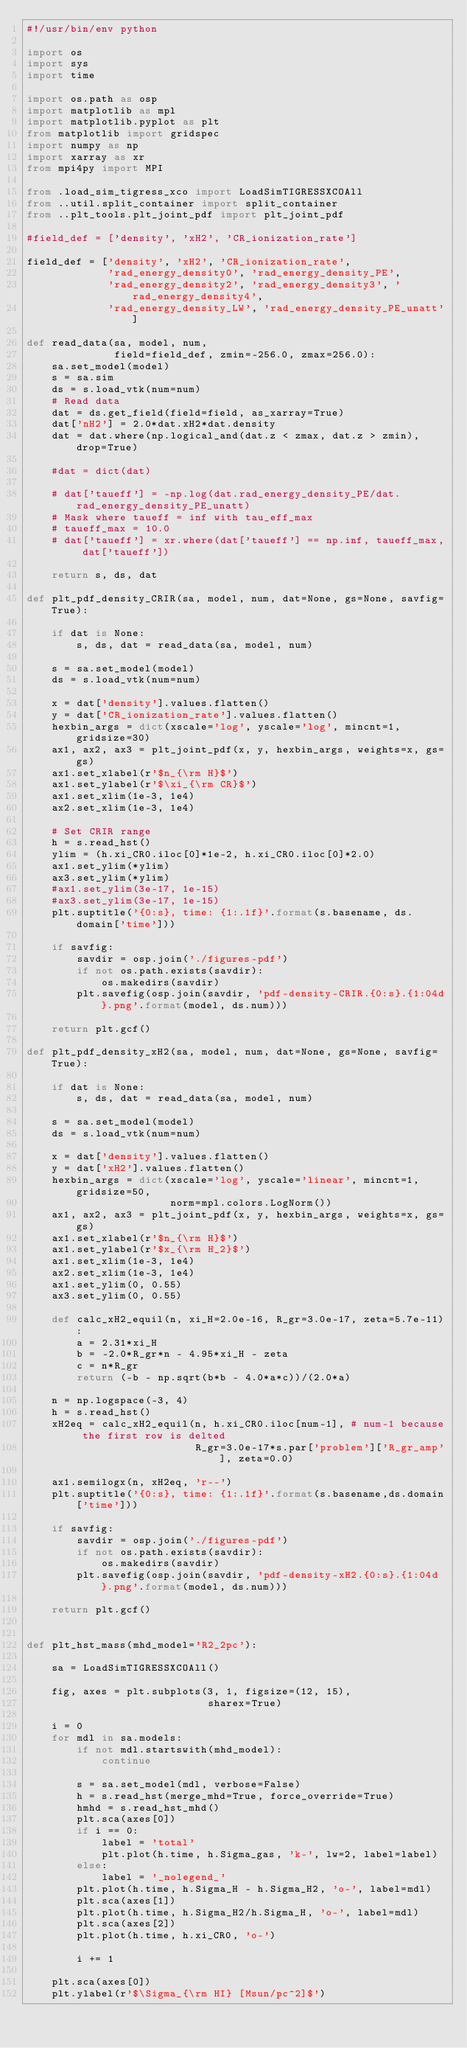<code> <loc_0><loc_0><loc_500><loc_500><_Python_>#!/usr/bin/env python

import os
import sys
import time

import os.path as osp
import matplotlib as mpl
import matplotlib.pyplot as plt
from matplotlib import gridspec
import numpy as np
import xarray as xr
from mpi4py import MPI

from .load_sim_tigress_xco import LoadSimTIGRESSXCOAll
from ..util.split_container import split_container
from ..plt_tools.plt_joint_pdf import plt_joint_pdf

#field_def = ['density', 'xH2', 'CR_ionization_rate']

field_def = ['density', 'xH2', 'CR_ionization_rate',
             'rad_energy_density0', 'rad_energy_density_PE',
             'rad_energy_density2', 'rad_energy_density3', 'rad_energy_density4',
             'rad_energy_density_LW', 'rad_energy_density_PE_unatt']

def read_data(sa, model, num,
              field=field_def, zmin=-256.0, zmax=256.0):
    sa.set_model(model)
    s = sa.sim
    ds = s.load_vtk(num=num)
    # Read data
    dat = ds.get_field(field=field, as_xarray=True)
    dat['nH2'] = 2.0*dat.xH2*dat.density
    dat = dat.where(np.logical_and(dat.z < zmax, dat.z > zmin), drop=True)

    #dat = dict(dat)

    # dat['taueff'] = -np.log(dat.rad_energy_density_PE/dat.rad_energy_density_PE_unatt)
    # Mask where taueff = inf with tau_eff_max
    # taueff_max = 10.0
    # dat['taueff'] = xr.where(dat['taueff'] == np.inf, taueff_max, dat['taueff'])
    
    return s, ds, dat

def plt_pdf_density_CRIR(sa, model, num, dat=None, gs=None, savfig=True):

    if dat is None:
        s, ds, dat = read_data(sa, model, num)

    s = sa.set_model(model)
    ds = s.load_vtk(num=num)
        
    x = dat['density'].values.flatten()
    y = dat['CR_ionization_rate'].values.flatten()
    hexbin_args = dict(xscale='log', yscale='log', mincnt=1, gridsize=30)
    ax1, ax2, ax3 = plt_joint_pdf(x, y, hexbin_args, weights=x, gs=gs)
    ax1.set_xlabel(r'$n_{\rm H}$')
    ax1.set_ylabel(r'$\xi_{\rm CR}$')
    ax1.set_xlim(1e-3, 1e4)
    ax2.set_xlim(1e-3, 1e4)

    # Set CRIR range
    h = s.read_hst()
    ylim = (h.xi_CR0.iloc[0]*1e-2, h.xi_CR0.iloc[0]*2.0)
    ax1.set_ylim(*ylim)
    ax3.set_ylim(*ylim)
    #ax1.set_ylim(3e-17, 1e-15)
    #ax3.set_ylim(3e-17, 1e-15)
    plt.suptitle('{0:s}, time: {1:.1f}'.format(s.basename, ds.domain['time']))
    
    if savfig:
        savdir = osp.join('./figures-pdf')
        if not os.path.exists(savdir):
            os.makedirs(savdir)
        plt.savefig(osp.join(savdir, 'pdf-density-CRIR.{0:s}.{1:04d}.png'.format(model, ds.num)))
    
    return plt.gcf()

def plt_pdf_density_xH2(sa, model, num, dat=None, gs=None, savfig=True):

    if dat is None:
        s, ds, dat = read_data(sa, model, num)
        
    s = sa.set_model(model)
    ds = s.load_vtk(num=num)

    x = dat['density'].values.flatten()
    y = dat['xH2'].values.flatten()
    hexbin_args = dict(xscale='log', yscale='linear', mincnt=1, gridsize=50,
                       norm=mpl.colors.LogNorm())
    ax1, ax2, ax3 = plt_joint_pdf(x, y, hexbin_args, weights=x, gs=gs)
    ax1.set_xlabel(r'$n_{\rm H}$')
    ax1.set_ylabel(r'$x_{\rm H_2}$')
    ax1.set_xlim(1e-3, 1e4)
    ax2.set_xlim(1e-3, 1e4)
    ax1.set_ylim(0, 0.55)
    ax3.set_ylim(0, 0.55)
    
    def calc_xH2_equil(n, xi_H=2.0e-16, R_gr=3.0e-17, zeta=5.7e-11):
        a = 2.31*xi_H
        b = -2.0*R_gr*n - 4.95*xi_H - zeta
        c = n*R_gr
        return (-b - np.sqrt(b*b - 4.0*a*c))/(2.0*a)
    
    n = np.logspace(-3, 4)
    h = s.read_hst()
    xH2eq = calc_xH2_equil(n, h.xi_CR0.iloc[num-1], # num-1 because the first row is delted
                           R_gr=3.0e-17*s.par['problem']['R_gr_amp'], zeta=0.0)
    
    ax1.semilogx(n, xH2eq, 'r--')
    plt.suptitle('{0:s}, time: {1:.1f}'.format(s.basename,ds.domain['time']))
    
    if savfig:
        savdir = osp.join('./figures-pdf')
        if not os.path.exists(savdir):
            os.makedirs(savdir)
        plt.savefig(osp.join(savdir, 'pdf-density-xH2.{0:s}.{1:04d}.png'.format(model, ds.num)))
        
    return plt.gcf()


def plt_hst_mass(mhd_model='R2_2pc'):

    sa = LoadSimTIGRESSXCOAll()
    
    fig, axes = plt.subplots(3, 1, figsize=(12, 15),
                             sharex=True)

    i = 0
    for mdl in sa.models:
        if not mdl.startswith(mhd_model):
            continue
        
        s = sa.set_model(mdl, verbose=False)
        h = s.read_hst(merge_mhd=True, force_override=True)
        hmhd = s.read_hst_mhd()
        plt.sca(axes[0])
        if i == 0:
            label = 'total'
            plt.plot(h.time, h.Sigma_gas, 'k-', lw=2, label=label)
        else:
            label = '_nolegend_'
        plt.plot(h.time, h.Sigma_H - h.Sigma_H2, 'o-', label=mdl)
        plt.sca(axes[1])
        plt.plot(h.time, h.Sigma_H2/h.Sigma_H, 'o-', label=mdl)
        plt.sca(axes[2])
        plt.plot(h.time, h.xi_CR0, 'o-')
        
        i += 1

    plt.sca(axes[0])
    plt.ylabel(r'$\Sigma_{\rm HI} [Msun/pc^2]$')</code> 